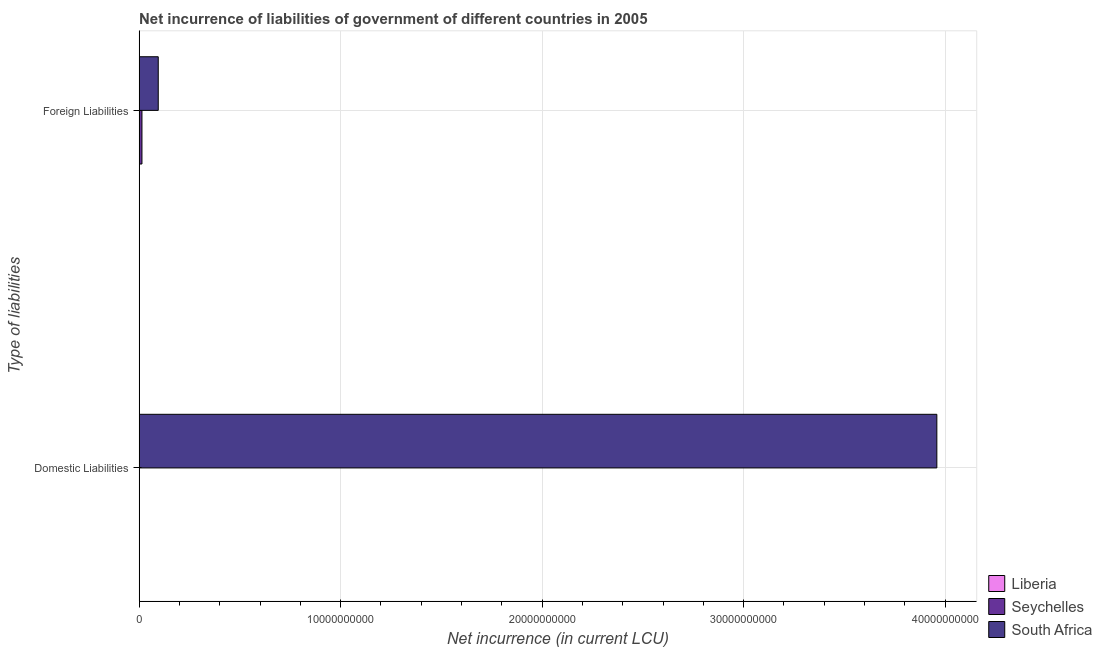How many bars are there on the 1st tick from the top?
Your answer should be very brief. 2. What is the label of the 1st group of bars from the top?
Ensure brevity in your answer.  Foreign Liabilities. What is the net incurrence of foreign liabilities in Seychelles?
Give a very brief answer. 1.42e+08. Across all countries, what is the maximum net incurrence of domestic liabilities?
Keep it short and to the point. 3.96e+1. In which country was the net incurrence of domestic liabilities maximum?
Offer a terse response. South Africa. What is the total net incurrence of domestic liabilities in the graph?
Provide a short and direct response. 3.96e+1. What is the difference between the net incurrence of foreign liabilities in South Africa and that in Seychelles?
Offer a very short reply. 8.08e+08. What is the difference between the net incurrence of foreign liabilities in Liberia and the net incurrence of domestic liabilities in Seychelles?
Your answer should be compact. 0. What is the average net incurrence of foreign liabilities per country?
Keep it short and to the point. 3.64e+08. What is the difference between the net incurrence of foreign liabilities and net incurrence of domestic liabilities in South Africa?
Your answer should be very brief. -3.86e+1. What is the ratio of the net incurrence of foreign liabilities in South Africa to that in Seychelles?
Your answer should be compact. 6.71. How many bars are there?
Your answer should be very brief. 3. Where does the legend appear in the graph?
Keep it short and to the point. Bottom right. What is the title of the graph?
Offer a very short reply. Net incurrence of liabilities of government of different countries in 2005. What is the label or title of the X-axis?
Keep it short and to the point. Net incurrence (in current LCU). What is the label or title of the Y-axis?
Offer a very short reply. Type of liabilities. What is the Net incurrence (in current LCU) of Liberia in Domestic Liabilities?
Your answer should be compact. 0. What is the Net incurrence (in current LCU) in South Africa in Domestic Liabilities?
Your answer should be very brief. 3.96e+1. What is the Net incurrence (in current LCU) of Liberia in Foreign Liabilities?
Provide a short and direct response. 0. What is the Net incurrence (in current LCU) in Seychelles in Foreign Liabilities?
Offer a terse response. 1.42e+08. What is the Net incurrence (in current LCU) in South Africa in Foreign Liabilities?
Ensure brevity in your answer.  9.50e+08. Across all Type of liabilities, what is the maximum Net incurrence (in current LCU) in Seychelles?
Keep it short and to the point. 1.42e+08. Across all Type of liabilities, what is the maximum Net incurrence (in current LCU) of South Africa?
Ensure brevity in your answer.  3.96e+1. Across all Type of liabilities, what is the minimum Net incurrence (in current LCU) in Seychelles?
Your answer should be very brief. 0. Across all Type of liabilities, what is the minimum Net incurrence (in current LCU) in South Africa?
Ensure brevity in your answer.  9.50e+08. What is the total Net incurrence (in current LCU) of Seychelles in the graph?
Offer a very short reply. 1.42e+08. What is the total Net incurrence (in current LCU) in South Africa in the graph?
Provide a succinct answer. 4.05e+1. What is the difference between the Net incurrence (in current LCU) of South Africa in Domestic Liabilities and that in Foreign Liabilities?
Offer a very short reply. 3.86e+1. What is the average Net incurrence (in current LCU) in Seychelles per Type of liabilities?
Offer a very short reply. 7.08e+07. What is the average Net incurrence (in current LCU) of South Africa per Type of liabilities?
Your response must be concise. 2.03e+1. What is the difference between the Net incurrence (in current LCU) of Seychelles and Net incurrence (in current LCU) of South Africa in Foreign Liabilities?
Give a very brief answer. -8.08e+08. What is the ratio of the Net incurrence (in current LCU) of South Africa in Domestic Liabilities to that in Foreign Liabilities?
Give a very brief answer. 41.67. What is the difference between the highest and the second highest Net incurrence (in current LCU) of South Africa?
Provide a short and direct response. 3.86e+1. What is the difference between the highest and the lowest Net incurrence (in current LCU) in Seychelles?
Keep it short and to the point. 1.42e+08. What is the difference between the highest and the lowest Net incurrence (in current LCU) of South Africa?
Your response must be concise. 3.86e+1. 